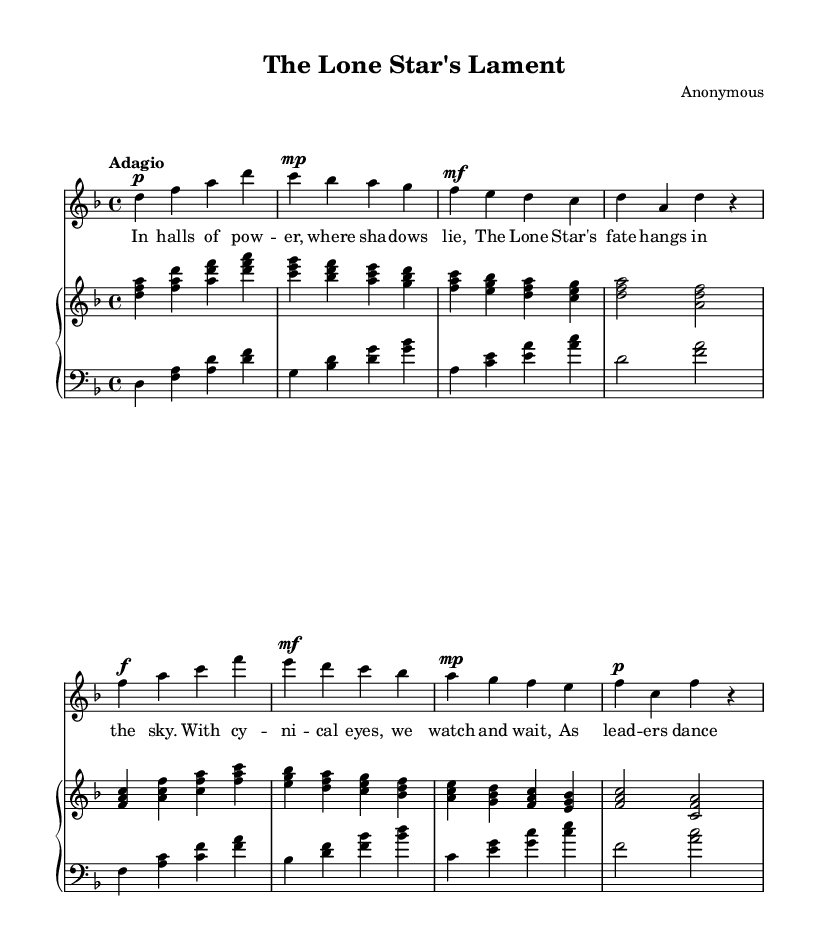What is the key signature of this music? The key signature indicated at the beginning of the sheet music shows two flats, which corresponds to the key of D minor.
Answer: D minor What is the time signature of this piece? The time signature shown at the beginning of the sheet music is 4/4, indicating that there are four beats in each measure and a quarter note gets one beat.
Answer: 4/4 What is the tempo marking for this composition? The tempo marking is "Adagio," which indicates a slow tempo, typically around 66-76 beats per minute.
Answer: Adagio How many measures are in the soprano part? The soprano part consists of eight measures as indicated by the notation, with each measure being clearly delineated.
Answer: Eight What dynamics are used in the soprano part? The dynamics indicated are piano, mezzo-piano, mezzo-forte, and forte, suggesting a range of soft to loud expressions throughout the piece.
Answer: Piano, mezzo-piano, mezzo-forte, forte Which poetic theme is explored in the lyrics? The lyrics discuss themes of power, fate, and the cynical observation of leadership, reflecting on political complexities and the uncertainty of governance.
Answer: Power and fate 